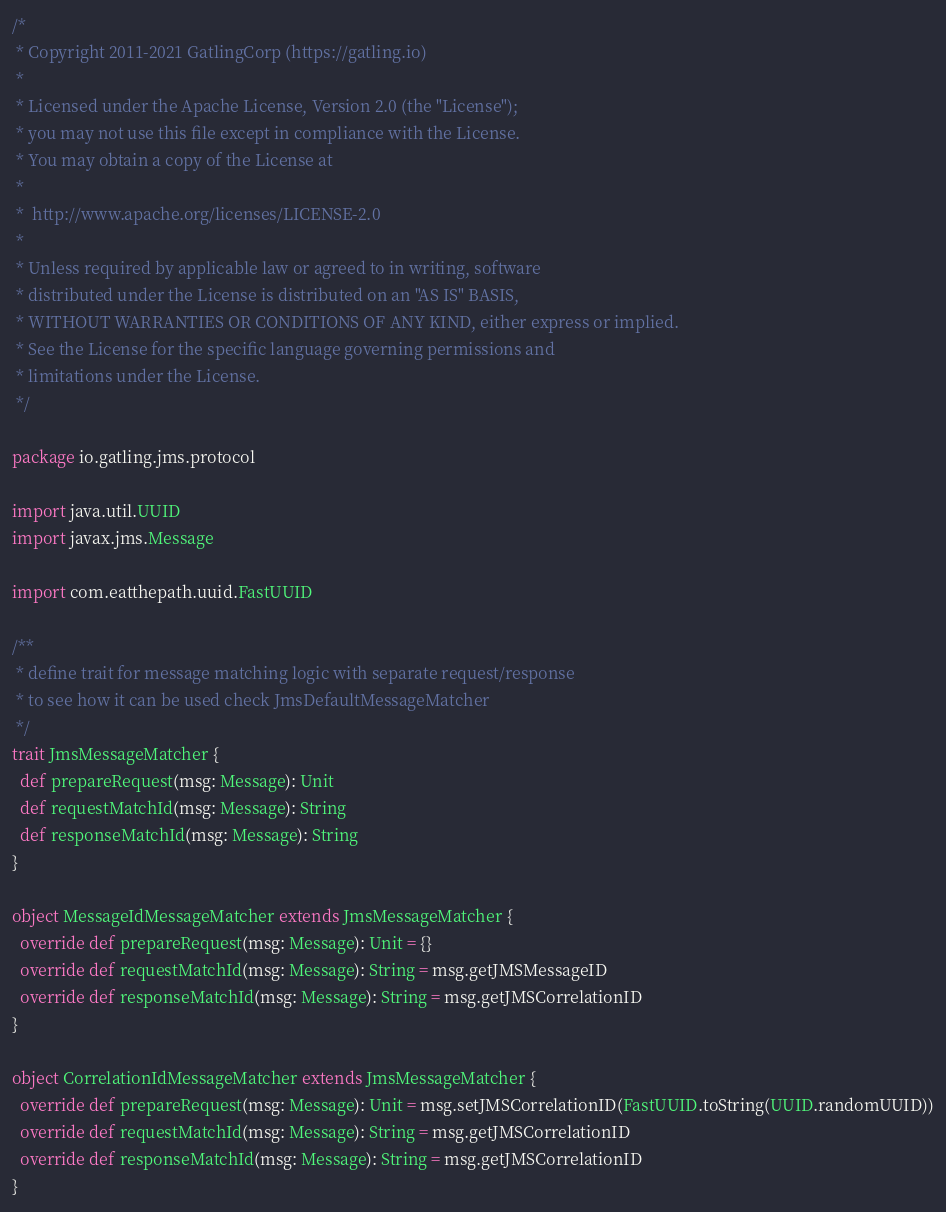<code> <loc_0><loc_0><loc_500><loc_500><_Scala_>/*
 * Copyright 2011-2021 GatlingCorp (https://gatling.io)
 *
 * Licensed under the Apache License, Version 2.0 (the "License");
 * you may not use this file except in compliance with the License.
 * You may obtain a copy of the License at
 *
 *  http://www.apache.org/licenses/LICENSE-2.0
 *
 * Unless required by applicable law or agreed to in writing, software
 * distributed under the License is distributed on an "AS IS" BASIS,
 * WITHOUT WARRANTIES OR CONDITIONS OF ANY KIND, either express or implied.
 * See the License for the specific language governing permissions and
 * limitations under the License.
 */

package io.gatling.jms.protocol

import java.util.UUID
import javax.jms.Message

import com.eatthepath.uuid.FastUUID

/**
 * define trait for message matching logic with separate request/response
 * to see how it can be used check JmsDefaultMessageMatcher
 */
trait JmsMessageMatcher {
  def prepareRequest(msg: Message): Unit
  def requestMatchId(msg: Message): String
  def responseMatchId(msg: Message): String
}

object MessageIdMessageMatcher extends JmsMessageMatcher {
  override def prepareRequest(msg: Message): Unit = {}
  override def requestMatchId(msg: Message): String = msg.getJMSMessageID
  override def responseMatchId(msg: Message): String = msg.getJMSCorrelationID
}

object CorrelationIdMessageMatcher extends JmsMessageMatcher {
  override def prepareRequest(msg: Message): Unit = msg.setJMSCorrelationID(FastUUID.toString(UUID.randomUUID))
  override def requestMatchId(msg: Message): String = msg.getJMSCorrelationID
  override def responseMatchId(msg: Message): String = msg.getJMSCorrelationID
}
</code> 